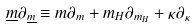Convert formula to latex. <formula><loc_0><loc_0><loc_500><loc_500>\underline { m } \partial _ { \underline { m } } \equiv m \partial _ { m } + m _ { H } \partial _ { m _ { H } } + \kappa \partial _ { \kappa }</formula> 